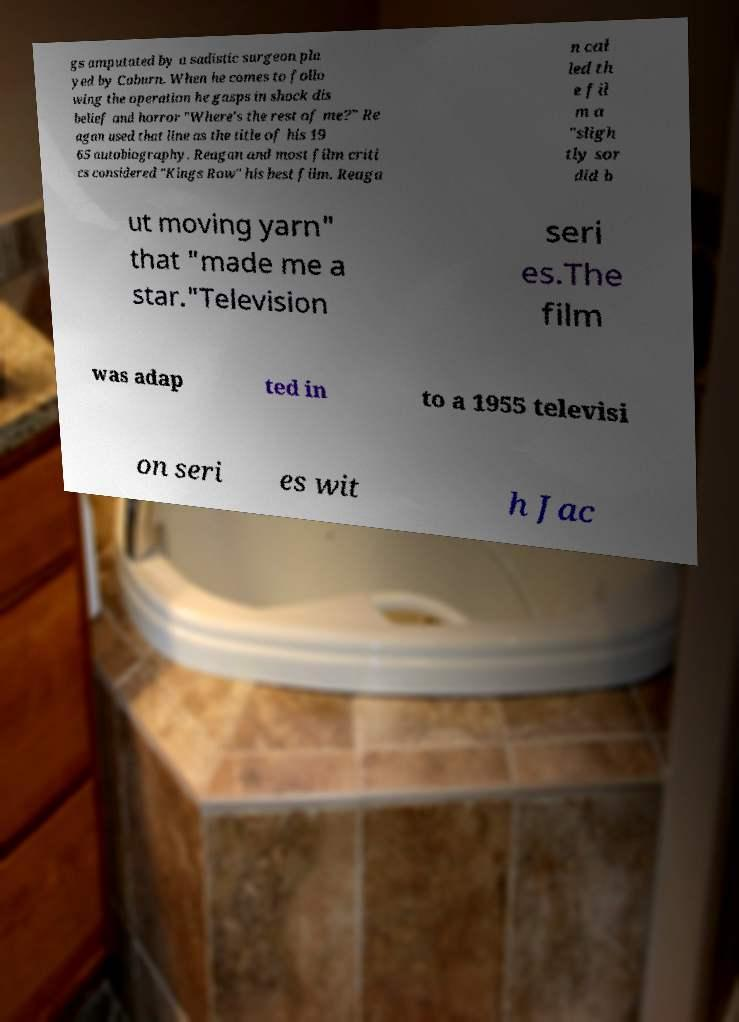Can you accurately transcribe the text from the provided image for me? gs amputated by a sadistic surgeon pla yed by Coburn. When he comes to follo wing the operation he gasps in shock dis belief and horror "Where's the rest of me?" Re agan used that line as the title of his 19 65 autobiography. Reagan and most film criti cs considered "Kings Row" his best film. Reaga n cal led th e fil m a "sligh tly sor did b ut moving yarn" that "made me a star."Television seri es.The film was adap ted in to a 1955 televisi on seri es wit h Jac 